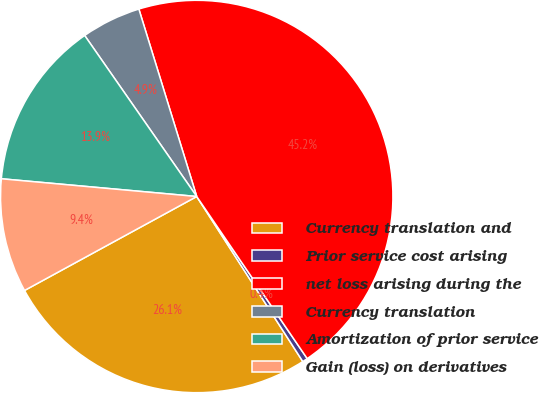Convert chart. <chart><loc_0><loc_0><loc_500><loc_500><pie_chart><fcel>Currency translation and<fcel>Prior service cost arising<fcel>net loss arising during the<fcel>Currency translation<fcel>Amortization of prior service<fcel>Gain (loss) on derivatives<nl><fcel>26.14%<fcel>0.43%<fcel>45.24%<fcel>4.91%<fcel>13.88%<fcel>9.39%<nl></chart> 